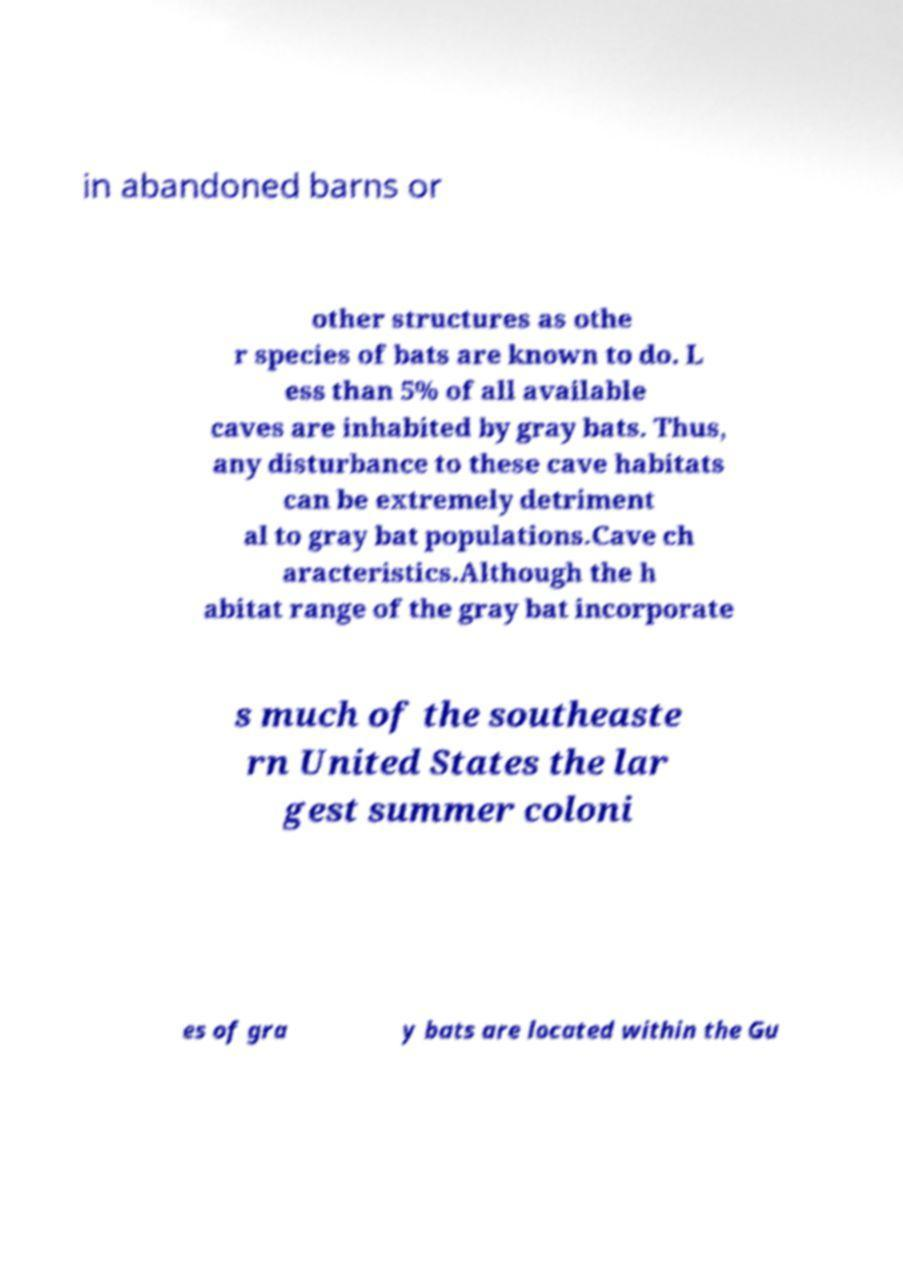Please identify and transcribe the text found in this image. in abandoned barns or other structures as othe r species of bats are known to do. L ess than 5% of all available caves are inhabited by gray bats. Thus, any disturbance to these cave habitats can be extremely detriment al to gray bat populations.Cave ch aracteristics.Although the h abitat range of the gray bat incorporate s much of the southeaste rn United States the lar gest summer coloni es of gra y bats are located within the Gu 